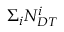<formula> <loc_0><loc_0><loc_500><loc_500>\Sigma _ { i } N _ { D T } ^ { i }</formula> 